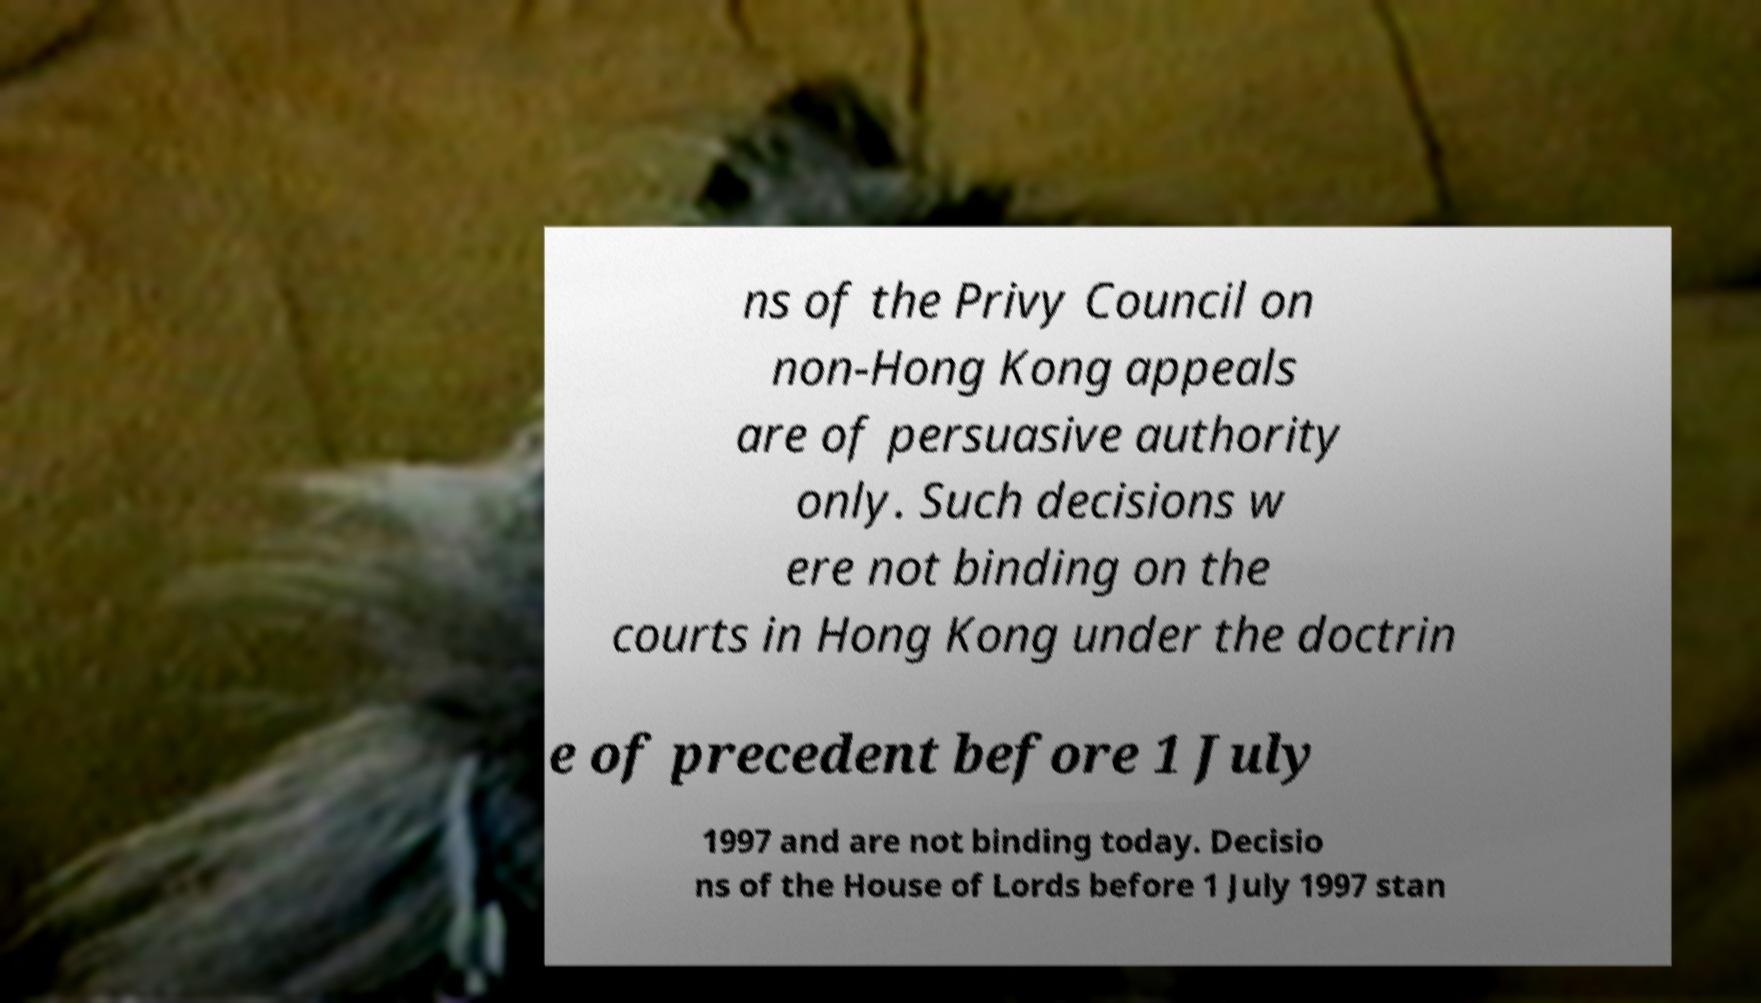Please identify and transcribe the text found in this image. ns of the Privy Council on non-Hong Kong appeals are of persuasive authority only. Such decisions w ere not binding on the courts in Hong Kong under the doctrin e of precedent before 1 July 1997 and are not binding today. Decisio ns of the House of Lords before 1 July 1997 stan 